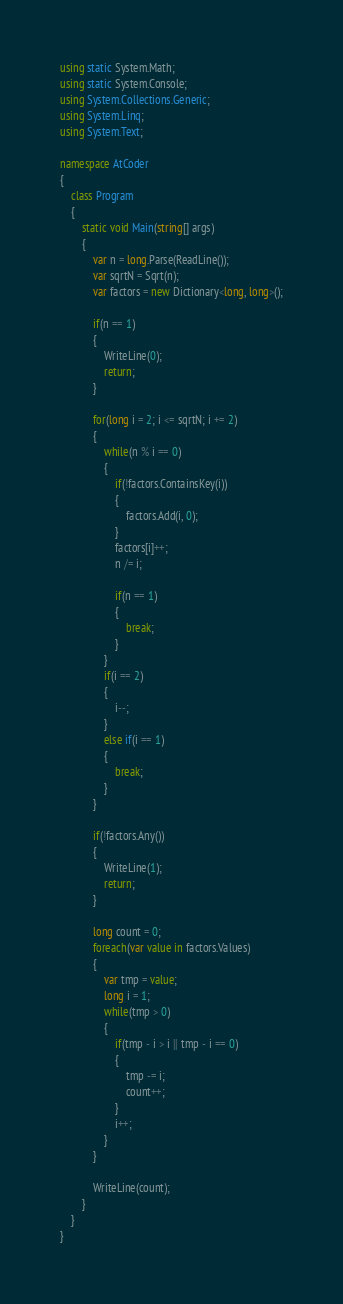Convert code to text. <code><loc_0><loc_0><loc_500><loc_500><_C#_>using static System.Math;
using static System.Console;
using System.Collections.Generic;
using System.Linq;
using System.Text;

namespace AtCoder
{
	class Program
	{
		static void Main(string[] args)
		{
			var n = long.Parse(ReadLine());
			var sqrtN = Sqrt(n);
			var factors = new Dictionary<long, long>();

			if(n == 1)
			{
				WriteLine(0);
				return;
			}

			for(long i = 2; i <= sqrtN; i += 2)
			{
				while(n % i == 0)
				{
					if(!factors.ContainsKey(i))
					{
						factors.Add(i, 0);
					}
					factors[i]++;
					n /= i;

					if(n == 1)
					{
						break;
					}
				}
				if(i == 2)
				{
					i--;
				}
				else if(i == 1)
				{
					break;
				}
			}

			if(!factors.Any())
			{
				WriteLine(1);
				return;
			}

			long count = 0;
			foreach(var value in factors.Values)
			{
				var tmp = value;
				long i = 1;
				while(tmp > 0)
				{
					if(tmp - i > i || tmp - i == 0)
					{
						tmp -= i;
						count++;
					}
					i++;
				}
			}

			WriteLine(count);
		}
	}
}
</code> 